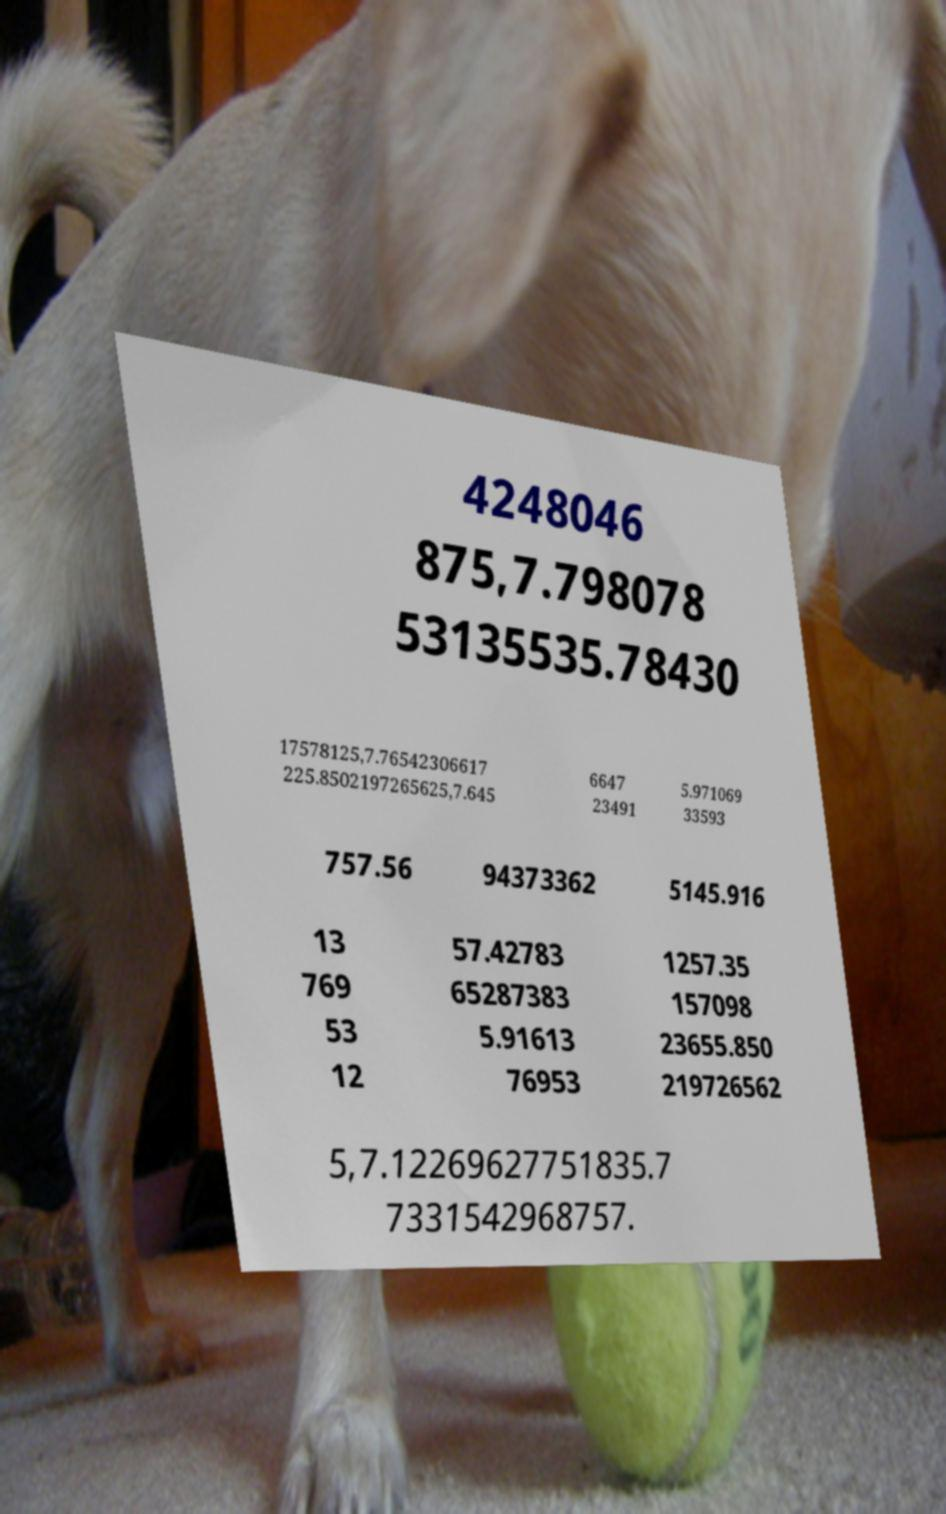Can you read and provide the text displayed in the image?This photo seems to have some interesting text. Can you extract and type it out for me? 4248046 875,7.798078 53135535.78430 17578125,7.76542306617 225.8502197265625,7.645 6647 23491 5.971069 33593 757.56 94373362 5145.916 13 769 53 12 57.42783 65287383 5.91613 76953 1257.35 157098 23655.850 219726562 5,7.12269627751835.7 7331542968757. 